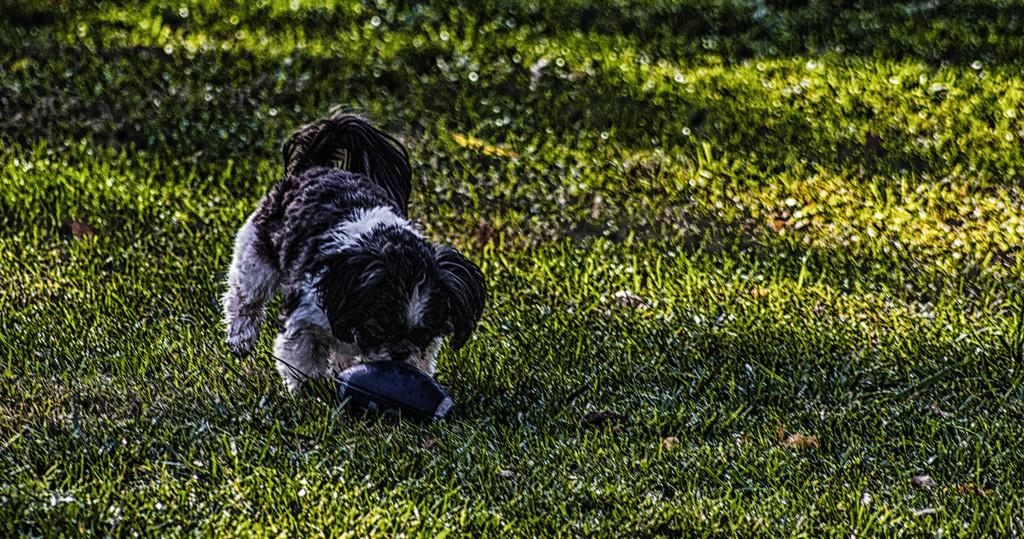What type of animal is in the image? There is a puppy in the image. What is the surface the puppy is standing on? The puppy is standing on grassland. What object is in front of the puppy? There is a ball in front of the puppy. What type of rose can be seen growing on the metal fence in the image? There is no rose or metal fence present in the image; it features a puppy standing on grassland with a ball in front of it. 